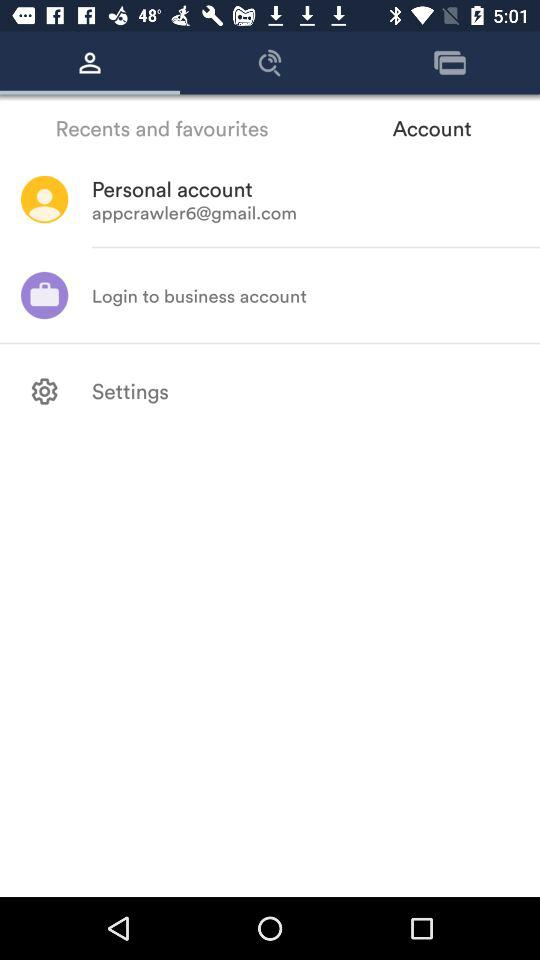Can we reset password?
When the provided information is insufficient, respond with <no answer>. <no answer> 